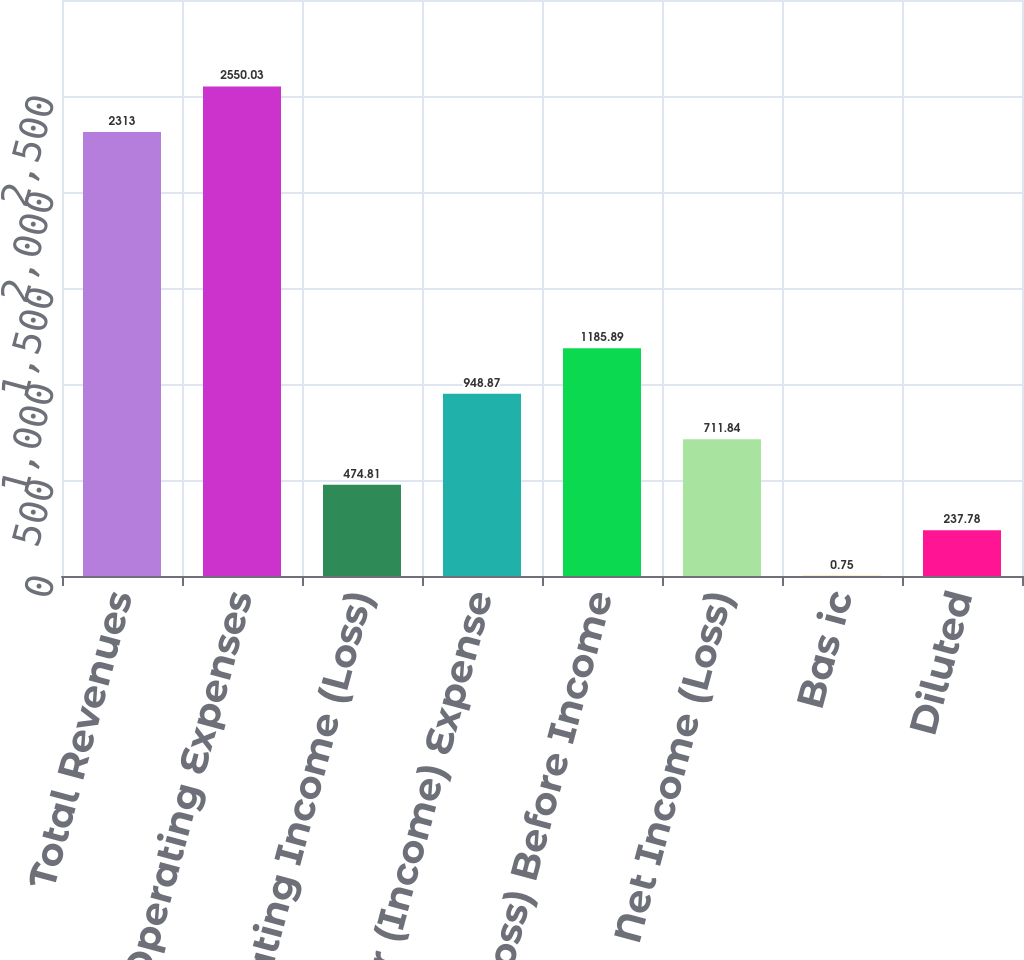Convert chart. <chart><loc_0><loc_0><loc_500><loc_500><bar_chart><fcel>Total Revenues<fcel>Total Operating Expenses<fcel>Operating Income (Loss)<fcel>Total Other (Income) Expense<fcel>Income (Loss) Before Income<fcel>Net Income (Loss)<fcel>Bas ic<fcel>Diluted<nl><fcel>2313<fcel>2550.03<fcel>474.81<fcel>948.87<fcel>1185.89<fcel>711.84<fcel>0.75<fcel>237.78<nl></chart> 